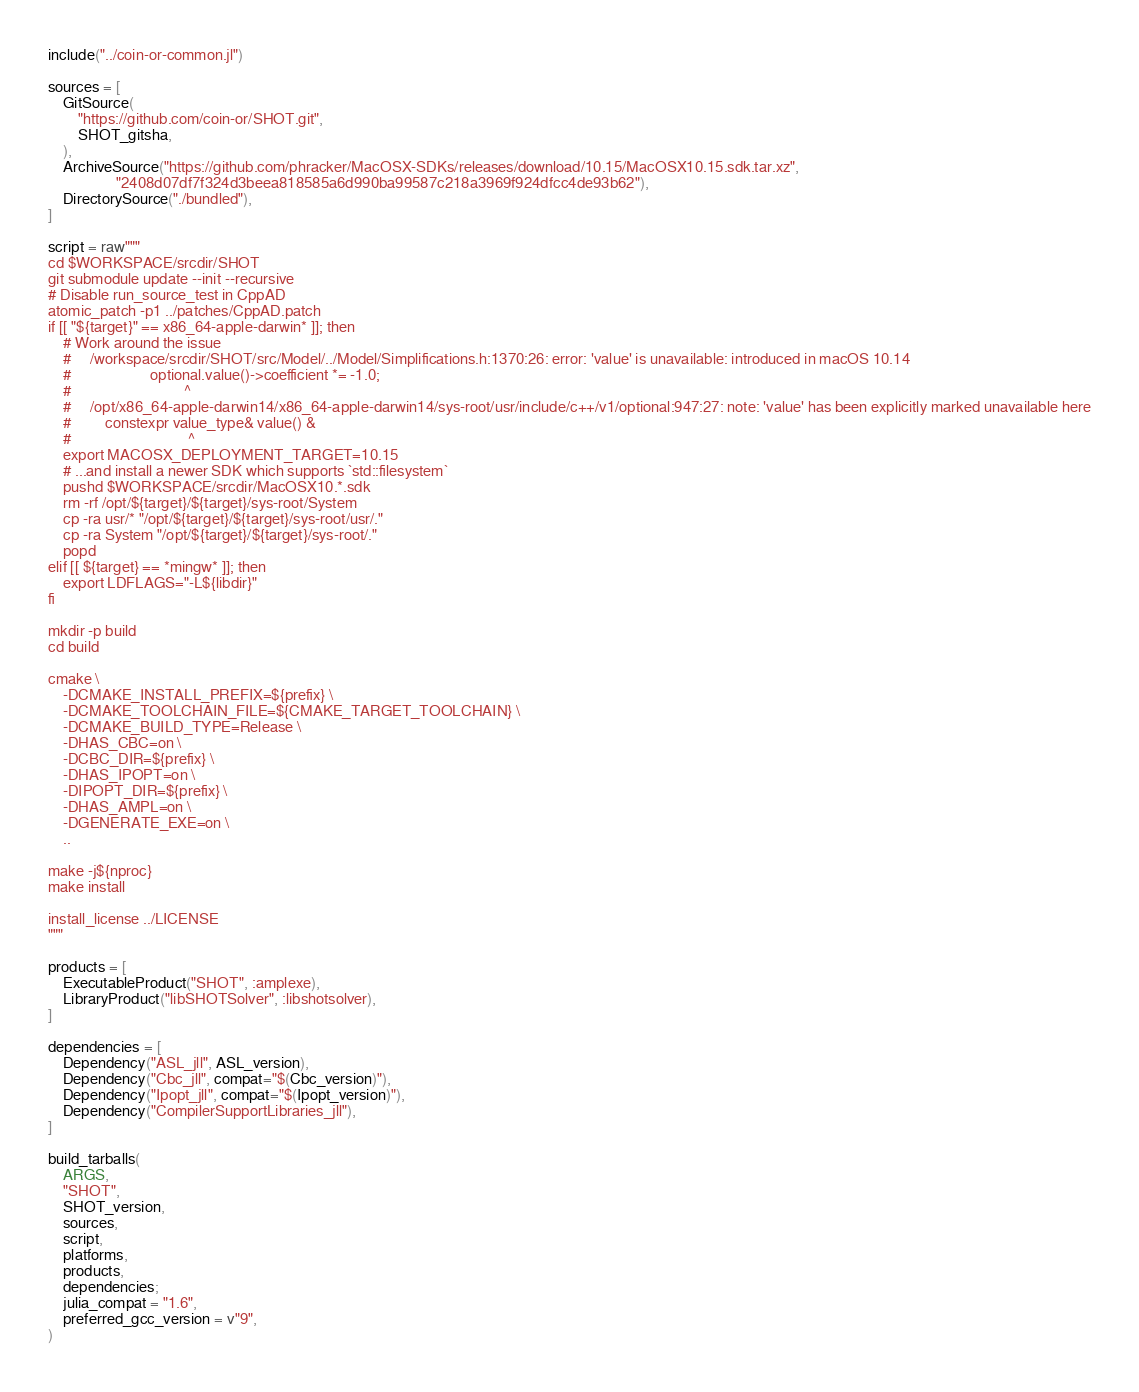Convert code to text. <code><loc_0><loc_0><loc_500><loc_500><_Julia_>include("../coin-or-common.jl")

sources = [
    GitSource(
        "https://github.com/coin-or/SHOT.git",
        SHOT_gitsha,
    ),
    ArchiveSource("https://github.com/phracker/MacOSX-SDKs/releases/download/10.15/MacOSX10.15.sdk.tar.xz",
                  "2408d07df7f324d3beea818585a6d990ba99587c218a3969f924dfcc4de93b62"),
    DirectorySource("./bundled"),
]

script = raw"""
cd $WORKSPACE/srcdir/SHOT
git submodule update --init --recursive
# Disable run_source_test in CppAD
atomic_patch -p1 ../patches/CppAD.patch
if [[ "${target}" == x86_64-apple-darwin* ]]; then
    # Work around the issue
    #     /workspace/srcdir/SHOT/src/Model/../Model/Simplifications.h:1370:26: error: 'value' is unavailable: introduced in macOS 10.14
    #                     optional.value()->coefficient *= -1.0;
    #                              ^
    #     /opt/x86_64-apple-darwin14/x86_64-apple-darwin14/sys-root/usr/include/c++/v1/optional:947:27: note: 'value' has been explicitly marked unavailable here
    #         constexpr value_type& value() &
    #                               ^
    export MACOSX_DEPLOYMENT_TARGET=10.15
    # ...and install a newer SDK which supports `std::filesystem`
    pushd $WORKSPACE/srcdir/MacOSX10.*.sdk
    rm -rf /opt/${target}/${target}/sys-root/System
    cp -ra usr/* "/opt/${target}/${target}/sys-root/usr/."
    cp -ra System "/opt/${target}/${target}/sys-root/."
    popd
elif [[ ${target} == *mingw* ]]; then
    export LDFLAGS="-L${libdir}"
fi

mkdir -p build
cd build

cmake \
    -DCMAKE_INSTALL_PREFIX=${prefix} \
    -DCMAKE_TOOLCHAIN_FILE=${CMAKE_TARGET_TOOLCHAIN} \
    -DCMAKE_BUILD_TYPE=Release \
    -DHAS_CBC=on \
    -DCBC_DIR=${prefix} \
    -DHAS_IPOPT=on \
    -DIPOPT_DIR=${prefix} \
    -DHAS_AMPL=on \
    -DGENERATE_EXE=on \
    ..

make -j${nproc}
make install

install_license ../LICENSE
"""

products = [
    ExecutableProduct("SHOT", :amplexe),
    LibraryProduct("libSHOTSolver", :libshotsolver),
]

dependencies = [
    Dependency("ASL_jll", ASL_version),
    Dependency("Cbc_jll", compat="$(Cbc_version)"),
    Dependency("Ipopt_jll", compat="$(Ipopt_version)"),
    Dependency("CompilerSupportLibraries_jll"),
]

build_tarballs(
    ARGS,
    "SHOT",
    SHOT_version,
    sources,
    script,
    platforms,
    products,
    dependencies;
    julia_compat = "1.6",
    preferred_gcc_version = v"9",
)
</code> 